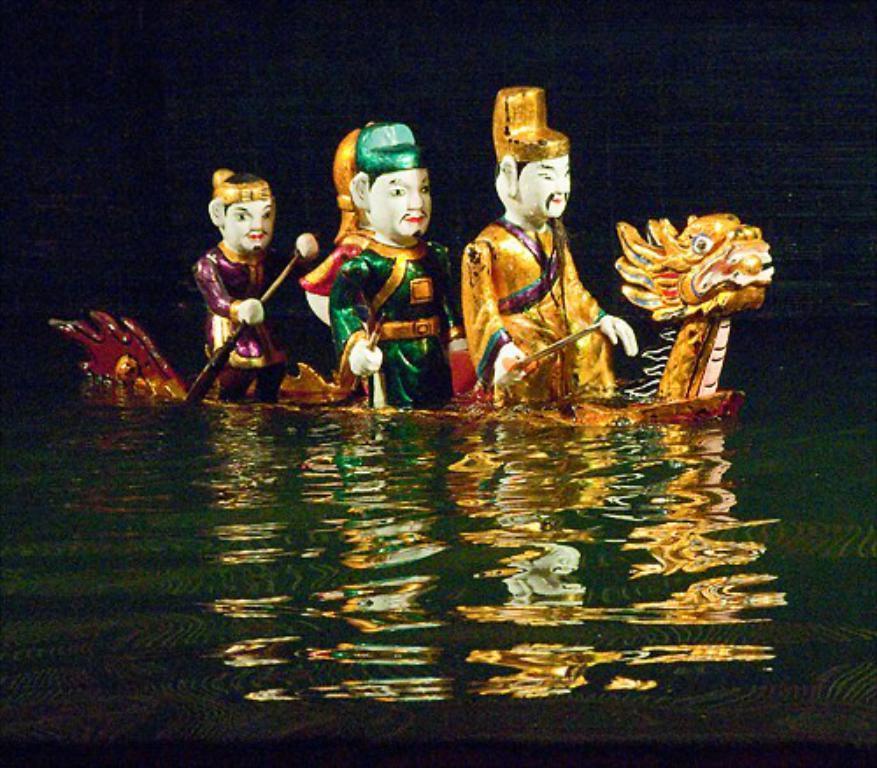Please provide a concise description of this image. Above this water we can see floating toys. Background it is dark. 